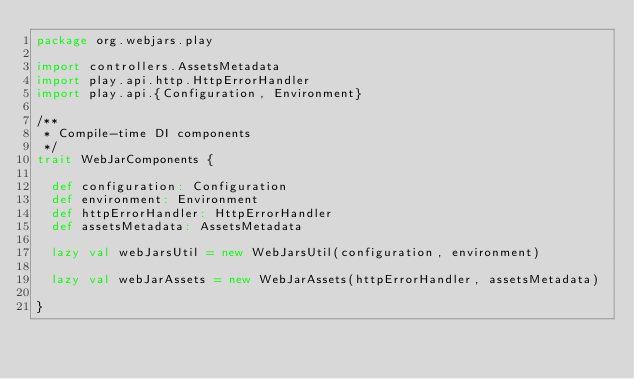Convert code to text. <code><loc_0><loc_0><loc_500><loc_500><_Scala_>package org.webjars.play

import controllers.AssetsMetadata
import play.api.http.HttpErrorHandler
import play.api.{Configuration, Environment}

/**
 * Compile-time DI components
 */
trait WebJarComponents {

  def configuration: Configuration
  def environment: Environment
  def httpErrorHandler: HttpErrorHandler
  def assetsMetadata: AssetsMetadata

  lazy val webJarsUtil = new WebJarsUtil(configuration, environment)

  lazy val webJarAssets = new WebJarAssets(httpErrorHandler, assetsMetadata)

}
</code> 